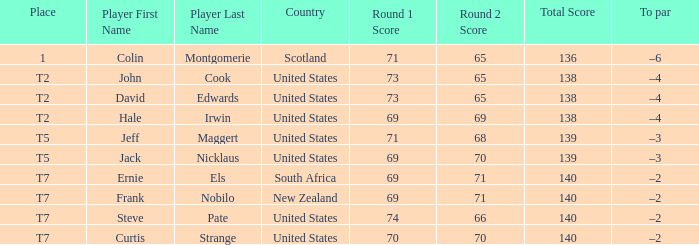Frank Nobilo plays for what country? New Zealand. 